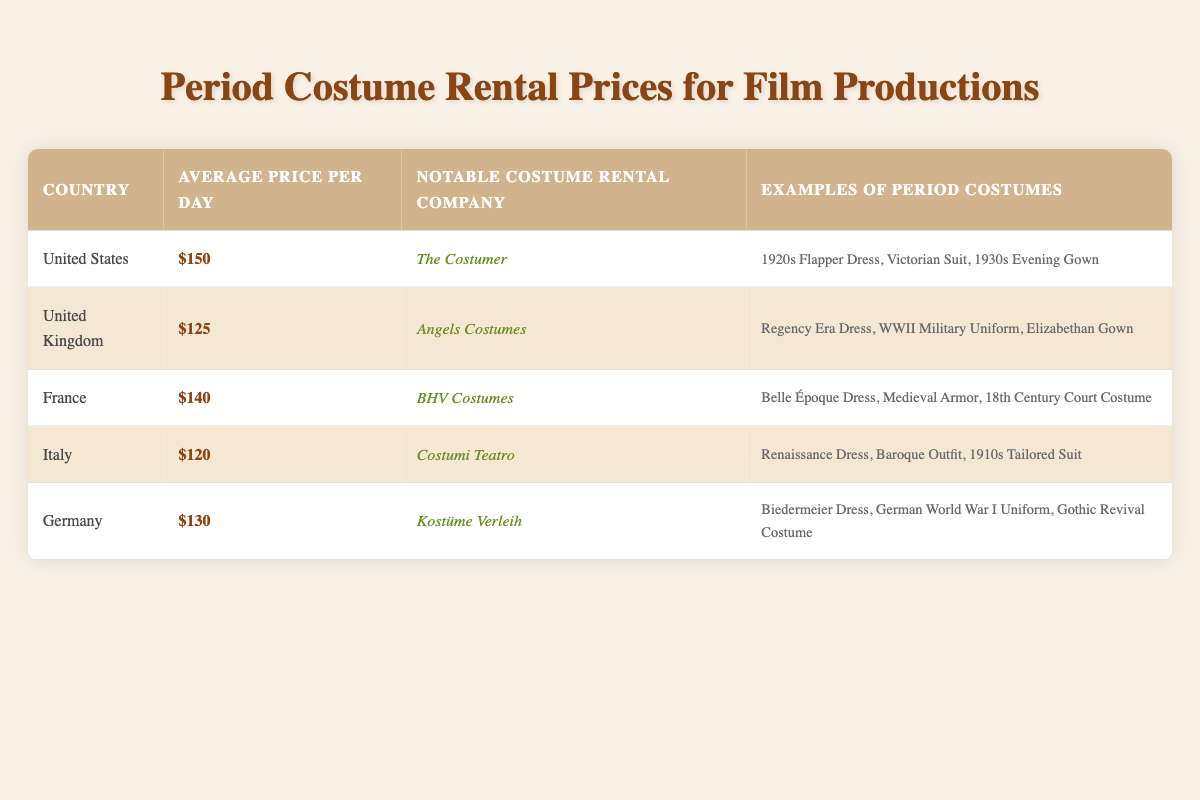What is the average price per day for renting period costumes in the United Kingdom? The table shows that the average price per day for renting period costumes in the United Kingdom is 125.
Answer: 125 Which country has the highest average rental price for period costumes? Looking at the average prices per day in the table, the United States has the highest average rental price at 150.
Answer: United States What notable costume rental company is associated with Italy? From the table, Costumi Teatro is listed as the notable costume rental company in Italy.
Answer: Costumi Teatro What is the difference in average rental price between the United States and Italy? The average price per day in the United States is 150, and in Italy, it is 120. The difference is calculated as 150 - 120 = 30.
Answer: 30 Are there any countries in the table where the average rental price is below 130? By examining the table, Italy (120) and the United Kingdom (125) both have average rental prices below 130.
Answer: Yes If you combine the average rental prices of France and Germany, what is the total? France has an average price of 140 and Germany has 130. Adding these together gives 140 + 130 = 270.
Answer: 270 Which country offers the lowest average price for renting period costumes? According to the table, Italy has the lowest average rental price at 120.
Answer: Italy Is there any country in the table that features “Victorian Suit” as an example of period costumes? The “Victorian Suit” is listed as an example under the United States in the table.
Answer: Yes What type of costume can be rented in France that is from the 18th century? The table specifies that 18th Century Court Costume can be rented in France.
Answer: 18th Century Court Costume 